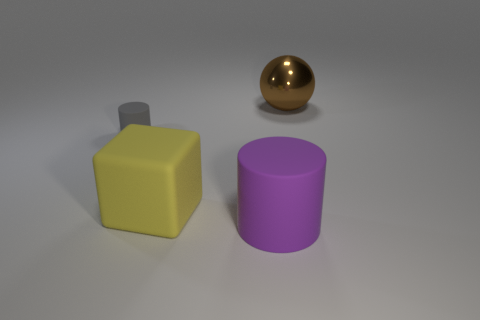Is there anything else that has the same material as the brown thing?
Your response must be concise. No. Are the purple cylinder and the gray cylinder made of the same material?
Your response must be concise. Yes. What is the size of the thing that is both behind the rubber cube and left of the big metal ball?
Provide a short and direct response. Small. There is a big brown shiny object; what shape is it?
Your answer should be compact. Sphere. What number of things are big purple rubber cylinders or objects that are behind the large yellow block?
Provide a short and direct response. 3. There is a thing that is both behind the yellow rubber block and on the right side of the small gray matte object; what is its color?
Ensure brevity in your answer.  Brown. There is a thing in front of the block; what is its material?
Provide a succinct answer. Rubber. What size is the gray rubber thing?
Your response must be concise. Small. How many brown things are either large rubber cylinders or large objects?
Your answer should be compact. 1. There is a cylinder that is to the left of the object that is in front of the large rubber block; what is its size?
Ensure brevity in your answer.  Small. 